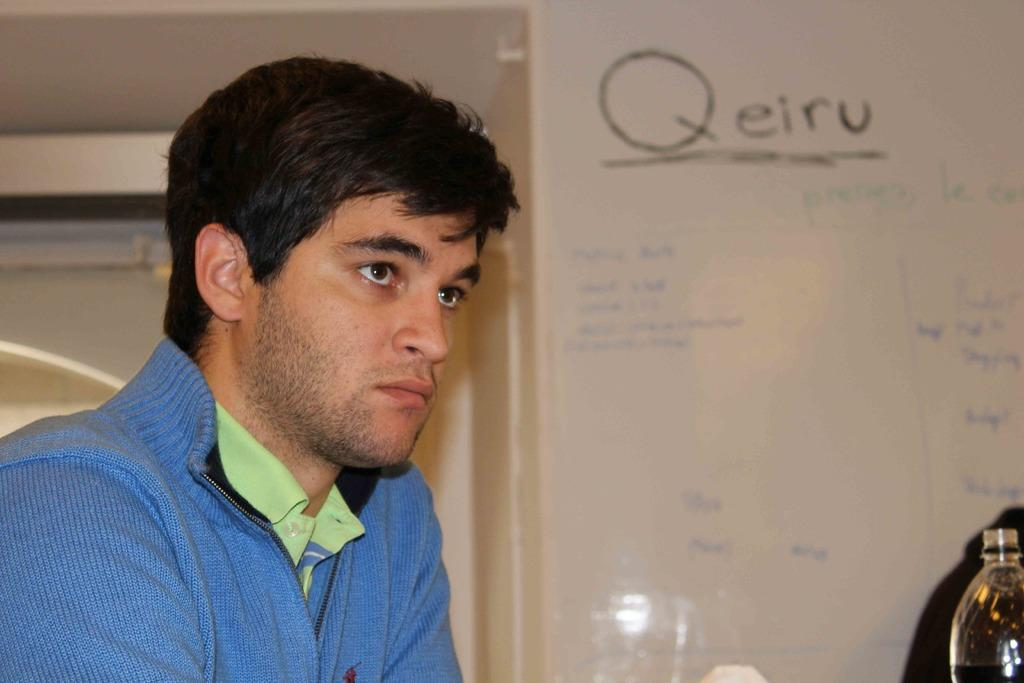What is the main subject of the image? There is a man in the image. What is the man doing in the image? The man is sitting at a table. What is the man's focus in the image? The man is looking at something. What type of ant can be seen crawling on the table in the image? There is no ant present in the image; the man is the main subject. 